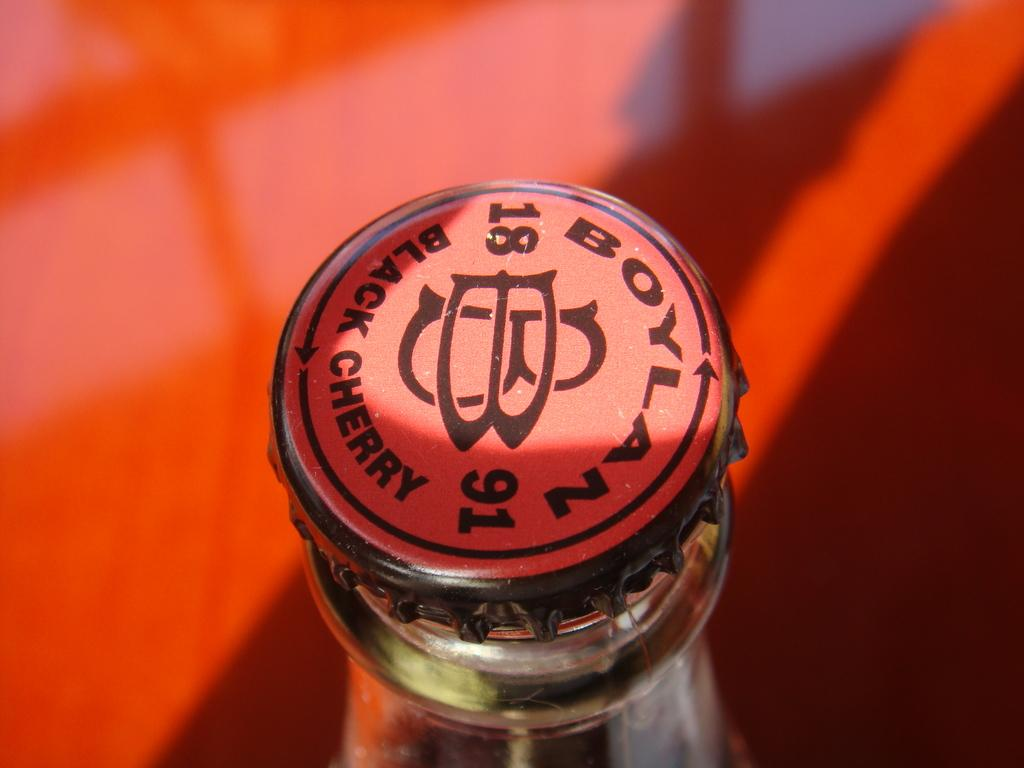Provide a one-sentence caption for the provided image. a top on a glass bottle with the words Black Cherry on it. 